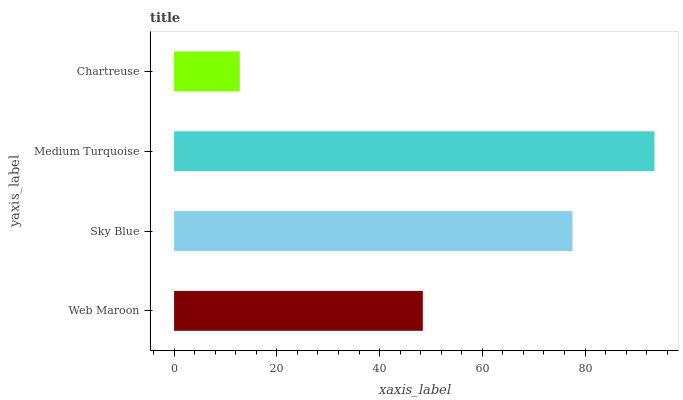Is Chartreuse the minimum?
Answer yes or no. Yes. Is Medium Turquoise the maximum?
Answer yes or no. Yes. Is Sky Blue the minimum?
Answer yes or no. No. Is Sky Blue the maximum?
Answer yes or no. No. Is Sky Blue greater than Web Maroon?
Answer yes or no. Yes. Is Web Maroon less than Sky Blue?
Answer yes or no. Yes. Is Web Maroon greater than Sky Blue?
Answer yes or no. No. Is Sky Blue less than Web Maroon?
Answer yes or no. No. Is Sky Blue the high median?
Answer yes or no. Yes. Is Web Maroon the low median?
Answer yes or no. Yes. Is Web Maroon the high median?
Answer yes or no. No. Is Chartreuse the low median?
Answer yes or no. No. 